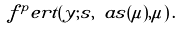Convert formula to latex. <formula><loc_0><loc_0><loc_500><loc_500>f ^ { p } e r t ( y ; s , \ a s ( \mu ) , \mu ) \, .</formula> 